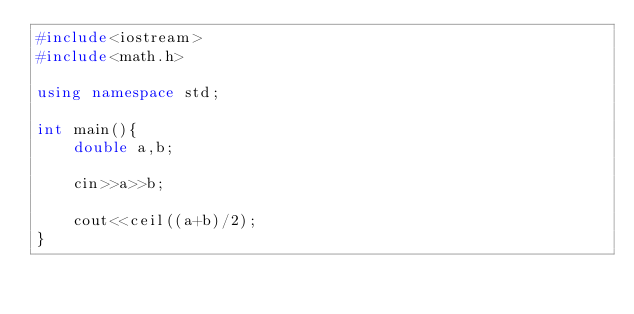<code> <loc_0><loc_0><loc_500><loc_500><_C++_>#include<iostream>
#include<math.h>

using namespace std;

int main(){
    double a,b;

    cin>>a>>b;

    cout<<ceil((a+b)/2);   
}</code> 